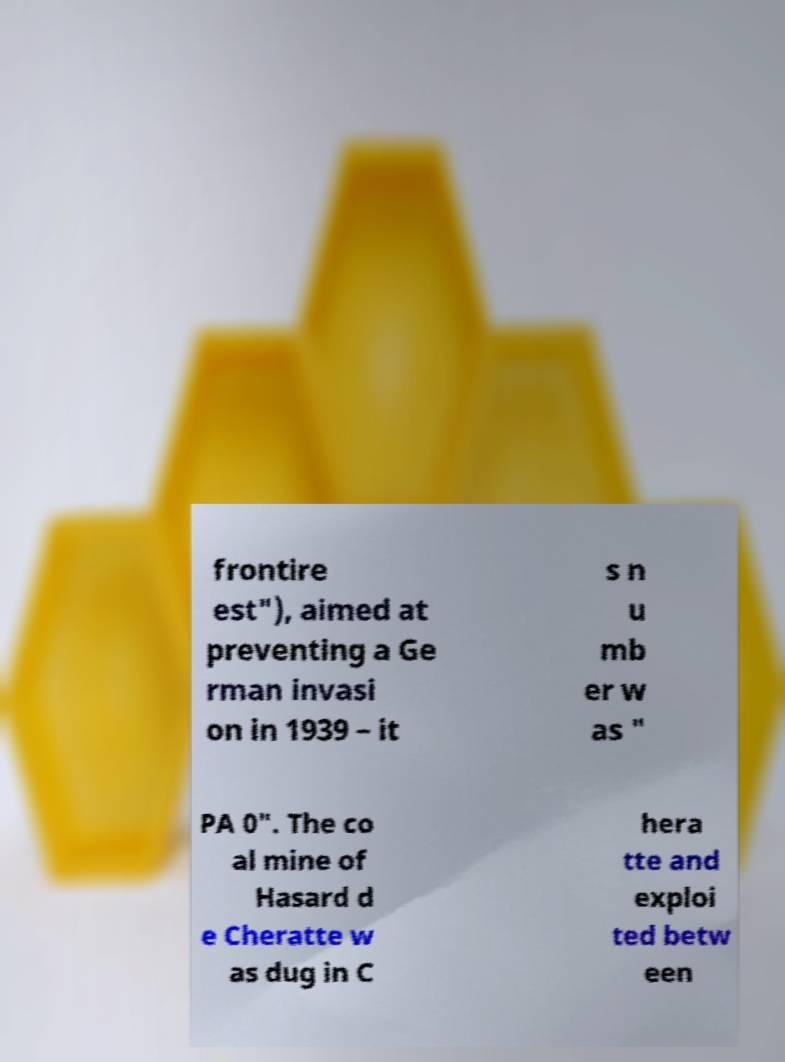Please identify and transcribe the text found in this image. frontire est"), aimed at preventing a Ge rman invasi on in 1939 – it s n u mb er w as " PA 0". The co al mine of Hasard d e Cheratte w as dug in C hera tte and exploi ted betw een 